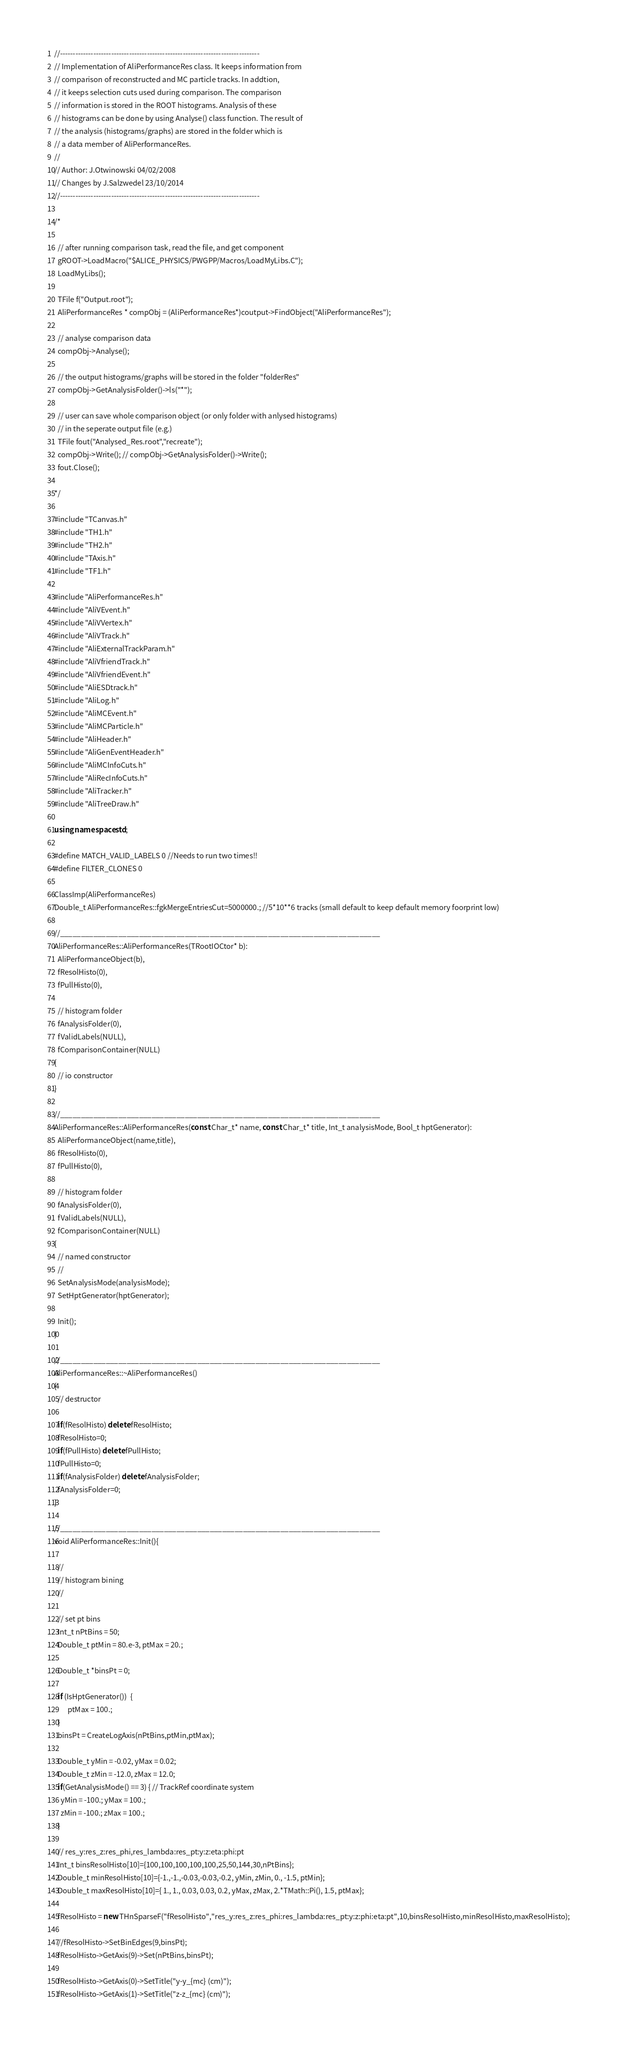Convert code to text. <code><loc_0><loc_0><loc_500><loc_500><_C++_>//------------------------------------------------------------------------------
// Implementation of AliPerformanceRes class. It keeps information from 
// comparison of reconstructed and MC particle tracks. In addtion, 
// it keeps selection cuts used during comparison. The comparison 
// information is stored in the ROOT histograms. Analysis of these 
// histograms can be done by using Analyse() class function. The result of 
// the analysis (histograms/graphs) are stored in the folder which is
// a data member of AliPerformanceRes.
//
// Author: J.Otwinowski 04/02/2008
// Changes by J.Salzwedel 23/10/2014
//------------------------------------------------------------------------------

/*
 
  // after running comparison task, read the file, and get component
  gROOT->LoadMacro("$ALICE_PHYSICS/PWGPP/Macros/LoadMyLibs.C");
  LoadMyLibs();

  TFile f("Output.root");
  AliPerformanceRes * compObj = (AliPerformanceRes*)coutput->FindObject("AliPerformanceRes");
 
  // analyse comparison data
  compObj->Analyse();

  // the output histograms/graphs will be stored in the folder "folderRes" 
  compObj->GetAnalysisFolder()->ls("*");

  // user can save whole comparison object (or only folder with anlysed histograms) 
  // in the seperate output file (e.g.)
  TFile fout("Analysed_Res.root","recreate");
  compObj->Write(); // compObj->GetAnalysisFolder()->Write();
  fout.Close();

*/

#include "TCanvas.h"
#include "TH1.h"
#include "TH2.h"
#include "TAxis.h"
#include "TF1.h"

#include "AliPerformanceRes.h" 
#include "AliVEvent.h"
#include "AliVVertex.h"
#include "AliVTrack.h"
#include "AliExternalTrackParam.h"
#include "AliVfriendTrack.h"
#include "AliVfriendEvent.h"
#include "AliESDtrack.h"
#include "AliLog.h" 
#include "AliMCEvent.h" 
#include "AliMCParticle.h" 
#include "AliHeader.h" 
#include "AliGenEventHeader.h" 
#include "AliMCInfoCuts.h" 
#include "AliRecInfoCuts.h" 
#include "AliTracker.h" 
#include "AliTreeDraw.h" 

using namespace std;

#define MATCH_VALID_LABELS 0 //Needs to run two times!!
#define FILTER_CLONES 0

ClassImp(AliPerformanceRes)
Double_t AliPerformanceRes::fgkMergeEntriesCut=5000000.; //5*10**6 tracks (small default to keep default memory foorprint low)

//_____________________________________________________________________________
AliPerformanceRes::AliPerformanceRes(TRootIOCtor* b):
  AliPerformanceObject(b),
  fResolHisto(0),
  fPullHisto(0),

  // histogram folder 
  fAnalysisFolder(0),
  fValidLabels(NULL),
  fComparisonContainer(NULL)
{
  // io constructor	
}

//_____________________________________________________________________________
AliPerformanceRes::AliPerformanceRes(const Char_t* name, const Char_t* title, Int_t analysisMode, Bool_t hptGenerator):
  AliPerformanceObject(name,title),
  fResolHisto(0),
  fPullHisto(0),

  // histogram folder 
  fAnalysisFolder(0),
  fValidLabels(NULL),
  fComparisonContainer(NULL)
{
  // named constructor	
  // 
  SetAnalysisMode(analysisMode);
  SetHptGenerator(hptGenerator);

  Init();
}

//_____________________________________________________________________________
AliPerformanceRes::~AliPerformanceRes()
{
  // destructor
   
  if(fResolHisto) delete fResolHisto;
  fResolHisto=0;     
  if(fPullHisto) delete fPullHisto;
  fPullHisto=0;     
  if(fAnalysisFolder) delete fAnalysisFolder;
  fAnalysisFolder=0;
}

//_____________________________________________________________________________
void AliPerformanceRes::Init(){

  //
  // histogram bining
  //

  // set pt bins
  Int_t nPtBins = 50;
  Double_t ptMin = 80.e-3, ptMax = 20.;

  Double_t *binsPt = 0;

  if (IsHptGenerator())  { 
        ptMax = 100.;
  } 
  binsPt = CreateLogAxis(nPtBins,ptMin,ptMax);

  Double_t yMin = -0.02, yMax = 0.02;
  Double_t zMin = -12.0, zMax = 12.0;
  if(GetAnalysisMode() == 3) { // TrackRef coordinate system
    yMin = -100.; yMax = 100.; 
    zMin = -100.; zMax = 100.; 
  }

  // res_y:res_z:res_phi,res_lambda:res_pt:y:z:eta:phi:pt
  Int_t binsResolHisto[10]={100,100,100,100,100,25,50,144,30,nPtBins};
  Double_t minResolHisto[10]={-1.,-1.,-0.03,-0.03,-0.2, yMin, zMin, 0., -1.5, ptMin};
  Double_t maxResolHisto[10]={ 1., 1., 0.03, 0.03, 0.2, yMax, zMax, 2.*TMath::Pi(), 1.5, ptMax};

  fResolHisto = new THnSparseF("fResolHisto","res_y:res_z:res_phi:res_lambda:res_pt:y:z:phi:eta:pt",10,binsResolHisto,minResolHisto,maxResolHisto);

  //fResolHisto->SetBinEdges(9,binsPt);
  fResolHisto->GetAxis(9)->Set(nPtBins,binsPt);

  fResolHisto->GetAxis(0)->SetTitle("y-y_{mc} (cm)");
  fResolHisto->GetAxis(1)->SetTitle("z-z_{mc} (cm)");</code> 